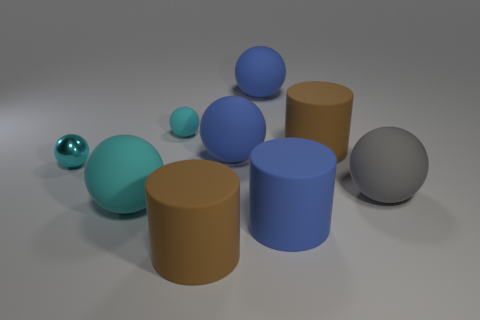How many cyan balls must be subtracted to get 1 cyan balls? 2 Subtract all red cubes. How many cyan balls are left? 3 Subtract all blue balls. How many balls are left? 4 Subtract all gray balls. How many balls are left? 5 Add 1 large blue matte objects. How many objects exist? 10 Subtract all red spheres. Subtract all cyan blocks. How many spheres are left? 6 Subtract all cylinders. How many objects are left? 6 Subtract 0 gray cylinders. How many objects are left? 9 Subtract all large cyan objects. Subtract all cyan objects. How many objects are left? 5 Add 6 large gray objects. How many large gray objects are left? 7 